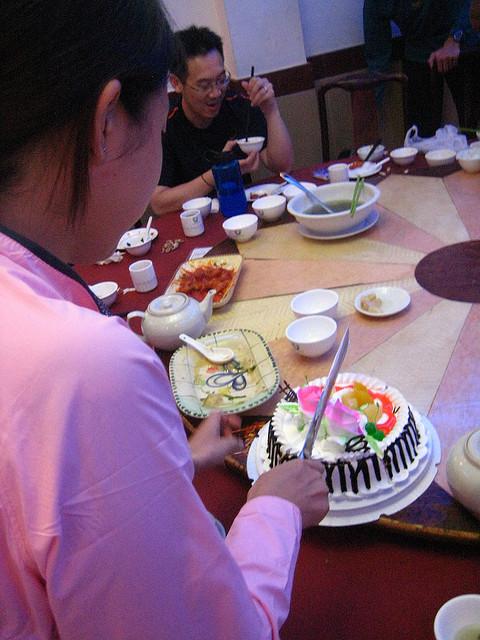Who is going to cut this birthday cake?
Concise answer only. Woman. Has anyone cut the cake yet?
Short answer required. No. What is the person in the center back using to eat?
Answer briefly. Chopsticks. What is this person cutting?
Give a very brief answer. Cake. Does it appear that they are celebrating something?
Be succinct. Yes. 